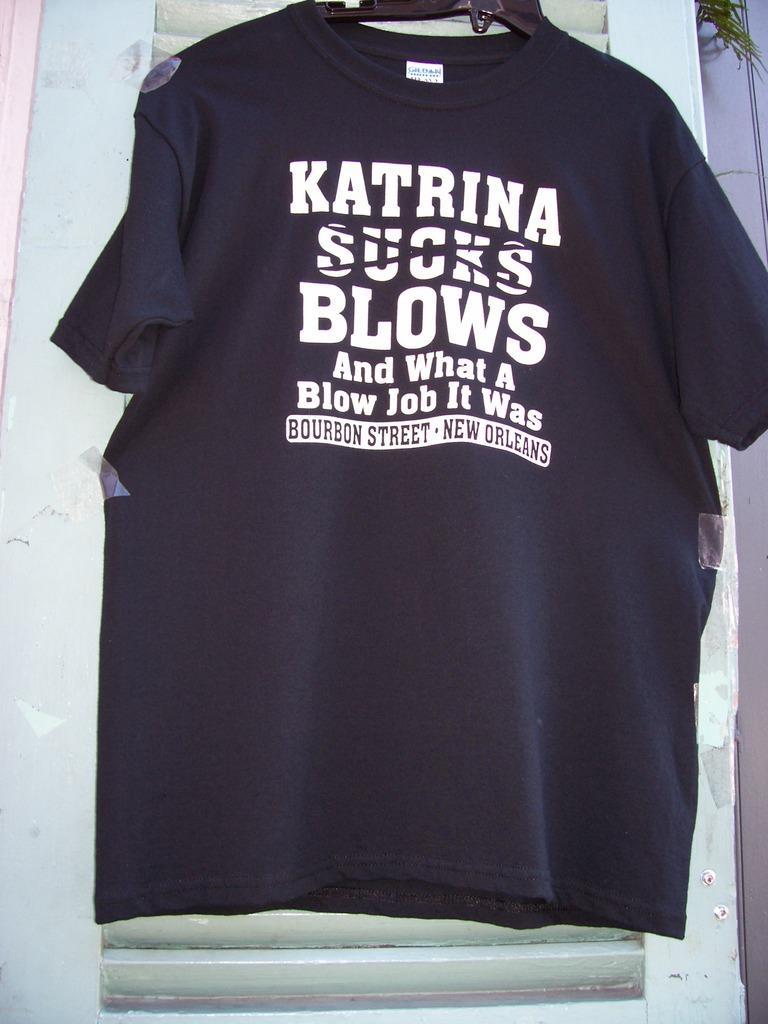Please provide a concise description of this image. In this image in the front there is a t-shirt which is black in colour with some text written on it. In the background there is a window which is white in colour, at the top right of the image there are leaves. 